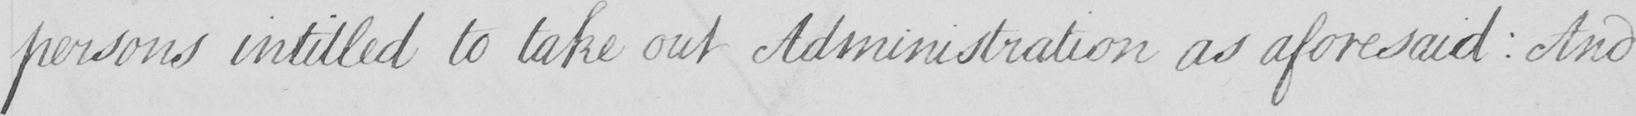What is written in this line of handwriting? persons intitled to take out Administration as aforesaid : And 